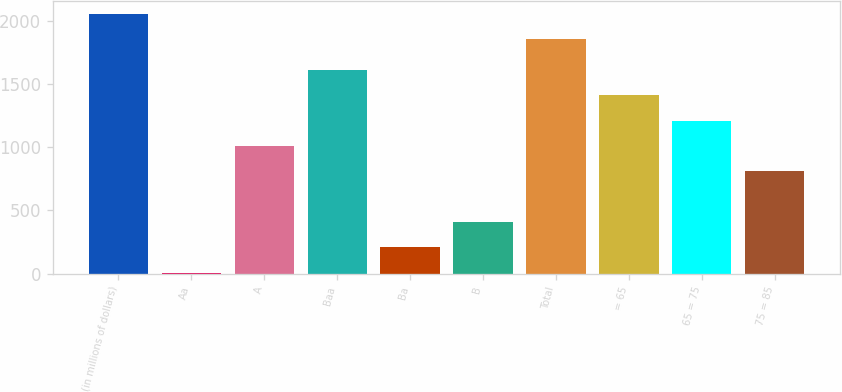Convert chart. <chart><loc_0><loc_0><loc_500><loc_500><bar_chart><fcel>(in millions of dollars)<fcel>Aa<fcel>A<fcel>Baa<fcel>Ba<fcel>B<fcel>Total<fcel>= 65<fcel>65 = 75<fcel>75 = 85<nl><fcel>2057.23<fcel>7.7<fcel>1010.85<fcel>1612.74<fcel>208.33<fcel>408.96<fcel>1856.6<fcel>1412.11<fcel>1211.48<fcel>810.22<nl></chart> 